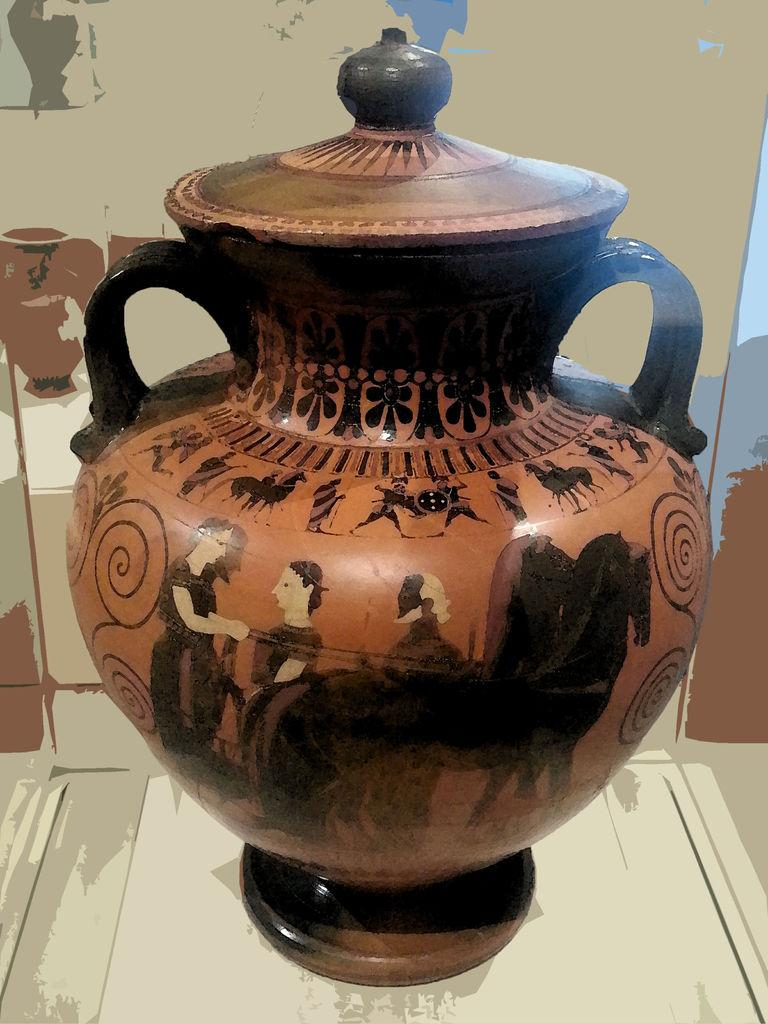What is the main object in the image? There is a vase with a lid in the image. What can be seen on the vase? The vase has paintings on it. What is visible in the background of the image? There is a wall in the background of the image. How many boats are visible in the image? There are no boats present in the image; it features a vase with a lid and paintings. What type of bushes can be seen growing near the vase in the image? There are no bushes visible in the image; it only shows a vase with a lid and paintings, as well as a wall in the background. 